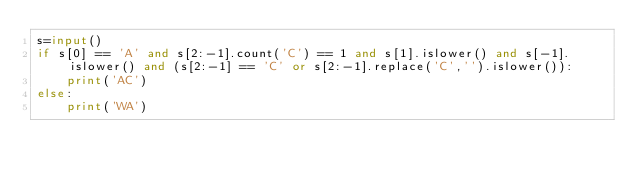<code> <loc_0><loc_0><loc_500><loc_500><_Python_>s=input()
if s[0] == 'A' and s[2:-1].count('C') == 1 and s[1].islower() and s[-1].islower() and (s[2:-1] == 'C' or s[2:-1].replace('C','').islower()):
    print('AC')
else:
    print('WA')</code> 